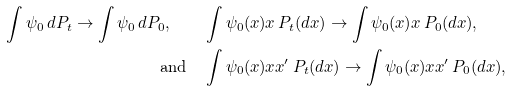<formula> <loc_0><loc_0><loc_500><loc_500>\int \psi _ { 0 } \, d P _ { t } \to \int \psi _ { 0 } \, d P _ { 0 } , \quad & \int \psi _ { 0 } ( x ) x \, P _ { t } ( d x ) \to \int \psi _ { 0 } ( x ) x \, P _ { 0 } ( d x ) , \\ \text {and} \quad & \int \psi _ { 0 } ( x ) x x ^ { \prime } \, P _ { t } ( d x ) \to \int \psi _ { 0 } ( x ) x x ^ { \prime } \, P _ { 0 } ( d x ) ,</formula> 